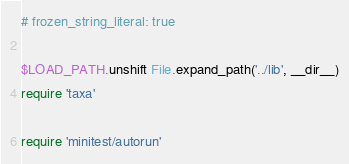<code> <loc_0><loc_0><loc_500><loc_500><_Ruby_># frozen_string_literal: true

$LOAD_PATH.unshift File.expand_path('../lib', __dir__)
require 'taxa'

require 'minitest/autorun'
</code> 